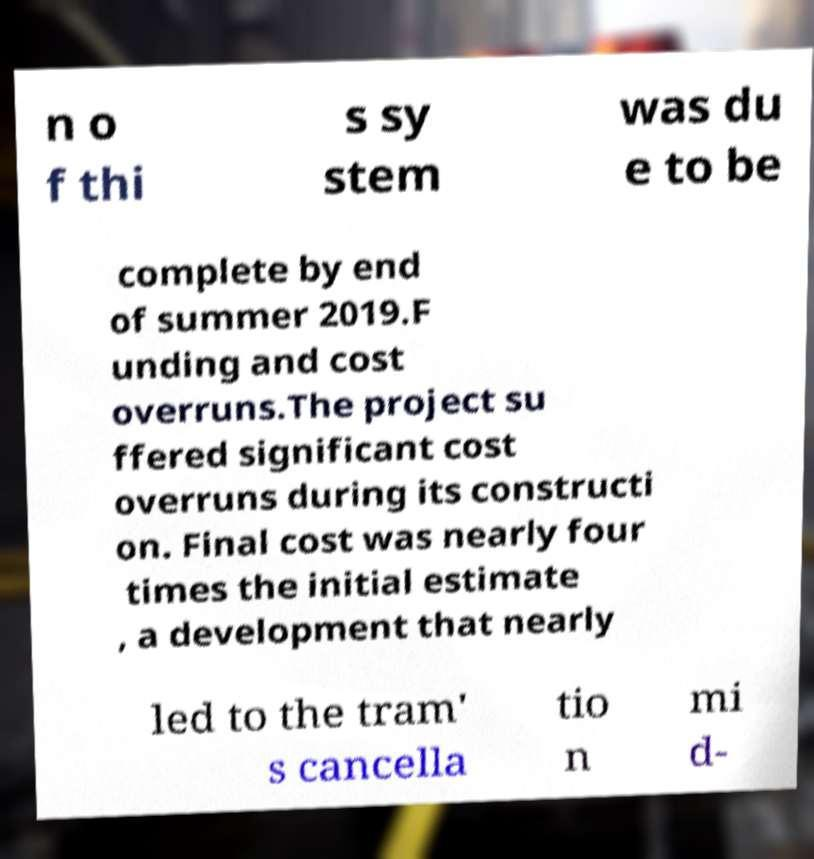There's text embedded in this image that I need extracted. Can you transcribe it verbatim? n o f thi s sy stem was du e to be complete by end of summer 2019.F unding and cost overruns.The project su ffered significant cost overruns during its constructi on. Final cost was nearly four times the initial estimate , a development that nearly led to the tram' s cancella tio n mi d- 